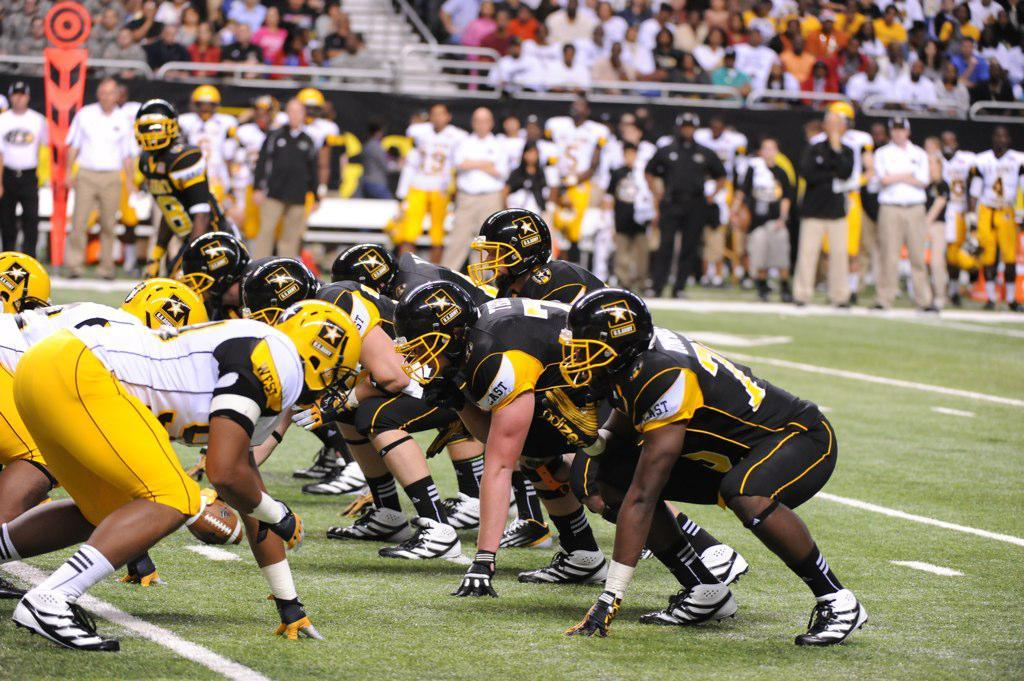What is happening in the background of the image? In the background of the image, there are persons standing and sitting. What is happening in the front of the image? In the front of the image, persons are playing. Are there any horses present in the image? No, there are no horses present in the image. What type of punishment is being administered to the persons in the image? There is no punishment being administered in the image; it shows persons standing, sitting, and playing. 